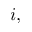<formula> <loc_0><loc_0><loc_500><loc_500>i ,</formula> 